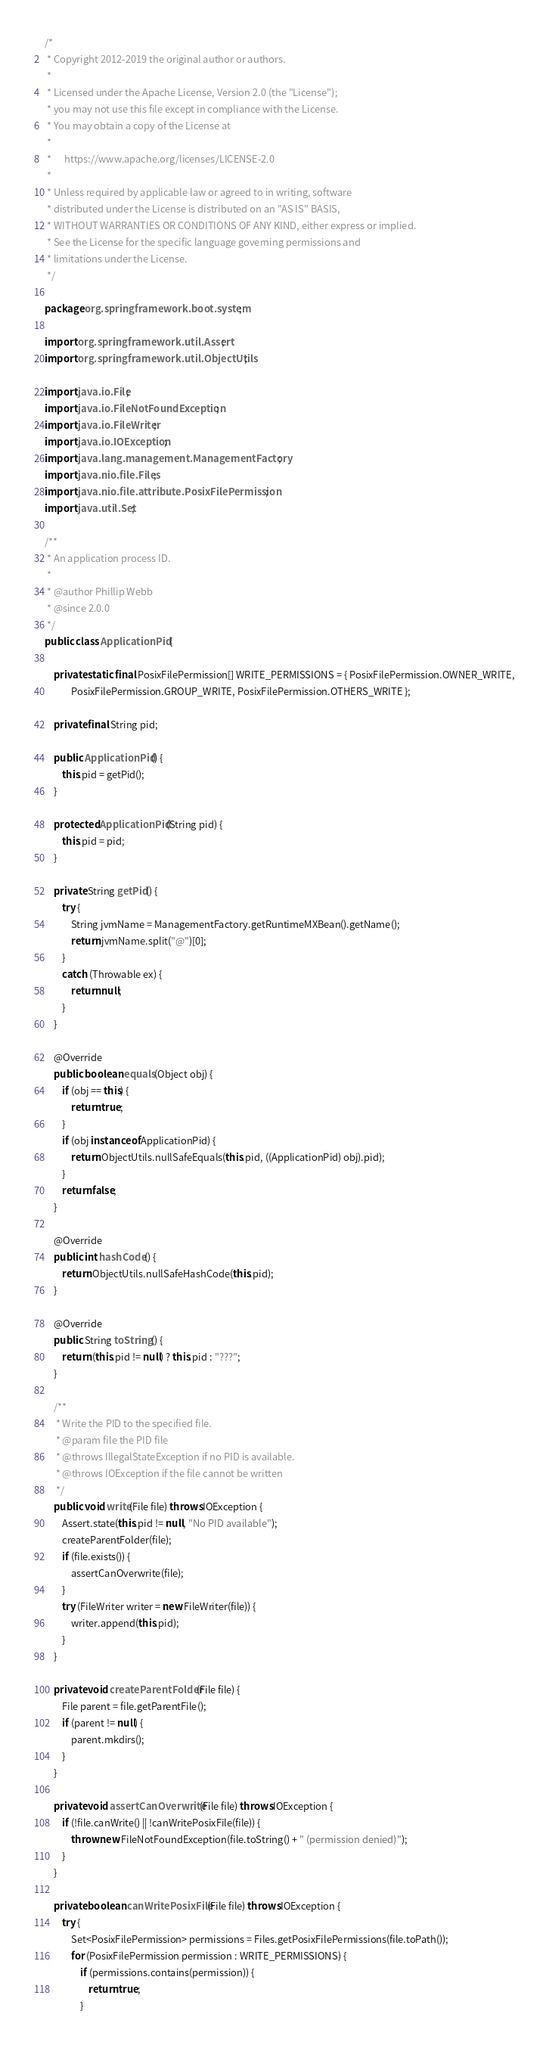Convert code to text. <code><loc_0><loc_0><loc_500><loc_500><_Java_>/*
 * Copyright 2012-2019 the original author or authors.
 *
 * Licensed under the Apache License, Version 2.0 (the "License");
 * you may not use this file except in compliance with the License.
 * You may obtain a copy of the License at
 *
 *      https://www.apache.org/licenses/LICENSE-2.0
 *
 * Unless required by applicable law or agreed to in writing, software
 * distributed under the License is distributed on an "AS IS" BASIS,
 * WITHOUT WARRANTIES OR CONDITIONS OF ANY KIND, either express or implied.
 * See the License for the specific language governing permissions and
 * limitations under the License.
 */

package org.springframework.boot.system;

import org.springframework.util.Assert;
import org.springframework.util.ObjectUtils;

import java.io.File;
import java.io.FileNotFoundException;
import java.io.FileWriter;
import java.io.IOException;
import java.lang.management.ManagementFactory;
import java.nio.file.Files;
import java.nio.file.attribute.PosixFilePermission;
import java.util.Set;

/**
 * An application process ID.
 *
 * @author Phillip Webb
 * @since 2.0.0
 */
public class ApplicationPid {

	private static final PosixFilePermission[] WRITE_PERMISSIONS = { PosixFilePermission.OWNER_WRITE,
			PosixFilePermission.GROUP_WRITE, PosixFilePermission.OTHERS_WRITE };

	private final String pid;

	public ApplicationPid() {
		this.pid = getPid();
	}

	protected ApplicationPid(String pid) {
		this.pid = pid;
	}

	private String getPid() {
		try {
			String jvmName = ManagementFactory.getRuntimeMXBean().getName();
			return jvmName.split("@")[0];
		}
		catch (Throwable ex) {
			return null;
		}
	}

	@Override
	public boolean equals(Object obj) {
		if (obj == this) {
			return true;
		}
		if (obj instanceof ApplicationPid) {
			return ObjectUtils.nullSafeEquals(this.pid, ((ApplicationPid) obj).pid);
		}
		return false;
	}

	@Override
	public int hashCode() {
		return ObjectUtils.nullSafeHashCode(this.pid);
	}

	@Override
	public String toString() {
		return (this.pid != null) ? this.pid : "???";
	}

	/**
	 * Write the PID to the specified file.
	 * @param file the PID file
	 * @throws IllegalStateException if no PID is available.
	 * @throws IOException if the file cannot be written
	 */
	public void write(File file) throws IOException {
		Assert.state(this.pid != null, "No PID available");
		createParentFolder(file);
		if (file.exists()) {
			assertCanOverwrite(file);
		}
		try (FileWriter writer = new FileWriter(file)) {
			writer.append(this.pid);
		}
	}

	private void createParentFolder(File file) {
		File parent = file.getParentFile();
		if (parent != null) {
			parent.mkdirs();
		}
	}

	private void assertCanOverwrite(File file) throws IOException {
		if (!file.canWrite() || !canWritePosixFile(file)) {
			throw new FileNotFoundException(file.toString() + " (permission denied)");
		}
	}

	private boolean canWritePosixFile(File file) throws IOException {
		try {
			Set<PosixFilePermission> permissions = Files.getPosixFilePermissions(file.toPath());
			for (PosixFilePermission permission : WRITE_PERMISSIONS) {
				if (permissions.contains(permission)) {
					return true;
				}</code> 